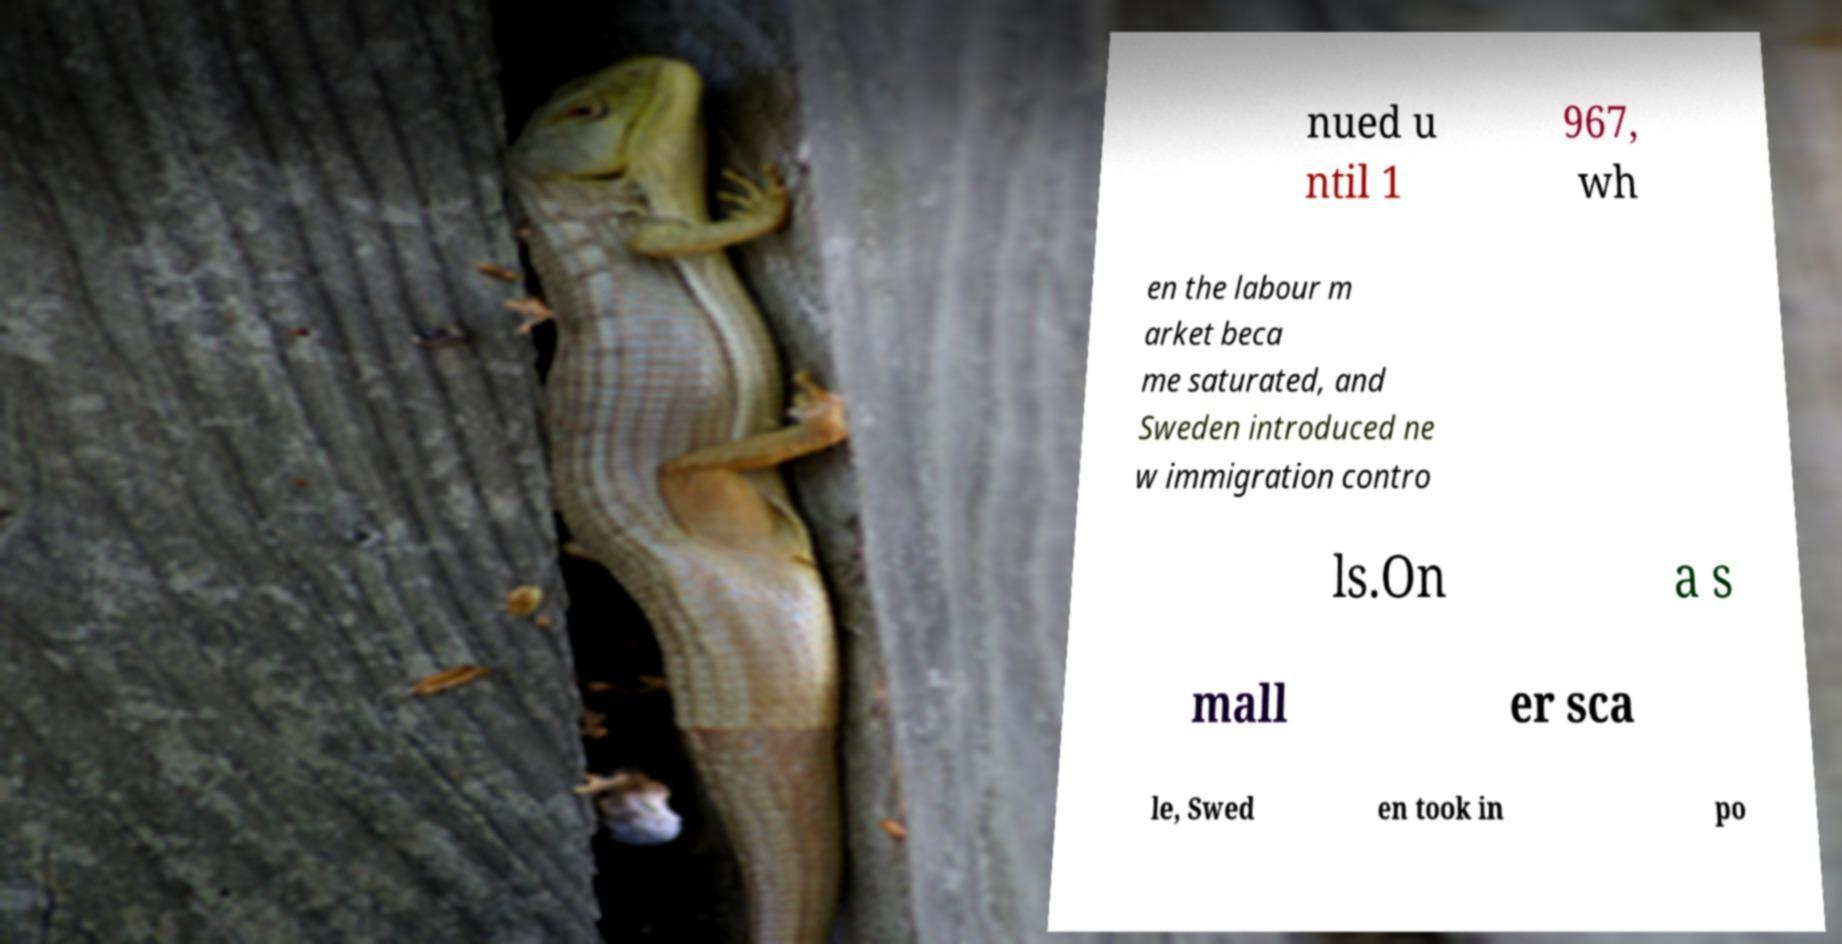What messages or text are displayed in this image? I need them in a readable, typed format. nued u ntil 1 967, wh en the labour m arket beca me saturated, and Sweden introduced ne w immigration contro ls.On a s mall er sca le, Swed en took in po 